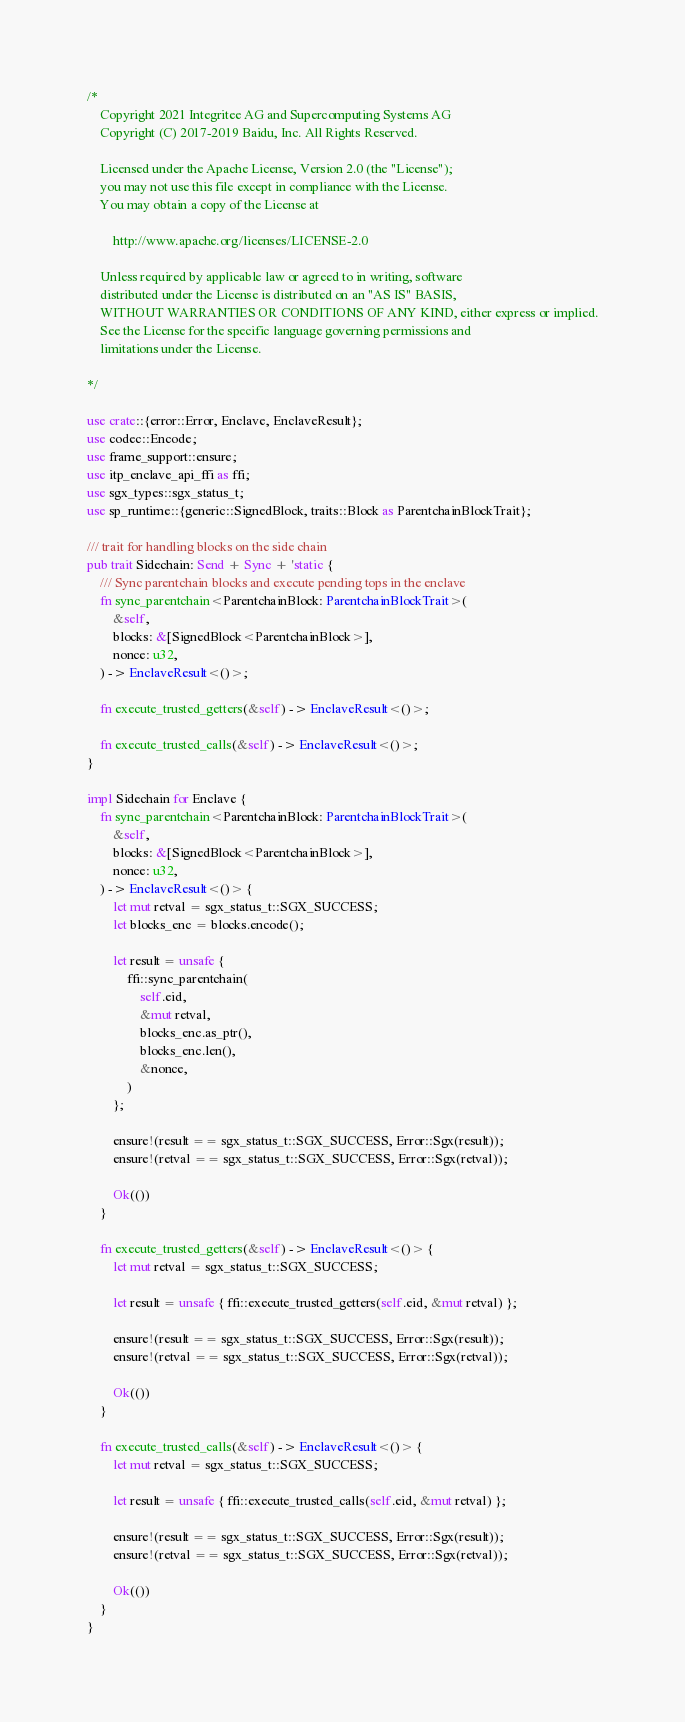Convert code to text. <code><loc_0><loc_0><loc_500><loc_500><_Rust_>/*
	Copyright 2021 Integritee AG and Supercomputing Systems AG
	Copyright (C) 2017-2019 Baidu, Inc. All Rights Reserved.

	Licensed under the Apache License, Version 2.0 (the "License");
	you may not use this file except in compliance with the License.
	You may obtain a copy of the License at

		http://www.apache.org/licenses/LICENSE-2.0

	Unless required by applicable law or agreed to in writing, software
	distributed under the License is distributed on an "AS IS" BASIS,
	WITHOUT WARRANTIES OR CONDITIONS OF ANY KIND, either express or implied.
	See the License for the specific language governing permissions and
	limitations under the License.

*/

use crate::{error::Error, Enclave, EnclaveResult};
use codec::Encode;
use frame_support::ensure;
use itp_enclave_api_ffi as ffi;
use sgx_types::sgx_status_t;
use sp_runtime::{generic::SignedBlock, traits::Block as ParentchainBlockTrait};

/// trait for handling blocks on the side chain
pub trait Sidechain: Send + Sync + 'static {
	/// Sync parentchain blocks and execute pending tops in the enclave
	fn sync_parentchain<ParentchainBlock: ParentchainBlockTrait>(
		&self,
		blocks: &[SignedBlock<ParentchainBlock>],
		nonce: u32,
	) -> EnclaveResult<()>;

	fn execute_trusted_getters(&self) -> EnclaveResult<()>;

	fn execute_trusted_calls(&self) -> EnclaveResult<()>;
}

impl Sidechain for Enclave {
	fn sync_parentchain<ParentchainBlock: ParentchainBlockTrait>(
		&self,
		blocks: &[SignedBlock<ParentchainBlock>],
		nonce: u32,
	) -> EnclaveResult<()> {
		let mut retval = sgx_status_t::SGX_SUCCESS;
		let blocks_enc = blocks.encode();

		let result = unsafe {
			ffi::sync_parentchain(
				self.eid,
				&mut retval,
				blocks_enc.as_ptr(),
				blocks_enc.len(),
				&nonce,
			)
		};

		ensure!(result == sgx_status_t::SGX_SUCCESS, Error::Sgx(result));
		ensure!(retval == sgx_status_t::SGX_SUCCESS, Error::Sgx(retval));

		Ok(())
	}

	fn execute_trusted_getters(&self) -> EnclaveResult<()> {
		let mut retval = sgx_status_t::SGX_SUCCESS;

		let result = unsafe { ffi::execute_trusted_getters(self.eid, &mut retval) };

		ensure!(result == sgx_status_t::SGX_SUCCESS, Error::Sgx(result));
		ensure!(retval == sgx_status_t::SGX_SUCCESS, Error::Sgx(retval));

		Ok(())
	}

	fn execute_trusted_calls(&self) -> EnclaveResult<()> {
		let mut retval = sgx_status_t::SGX_SUCCESS;

		let result = unsafe { ffi::execute_trusted_calls(self.eid, &mut retval) };

		ensure!(result == sgx_status_t::SGX_SUCCESS, Error::Sgx(result));
		ensure!(retval == sgx_status_t::SGX_SUCCESS, Error::Sgx(retval));

		Ok(())
	}
}
</code> 